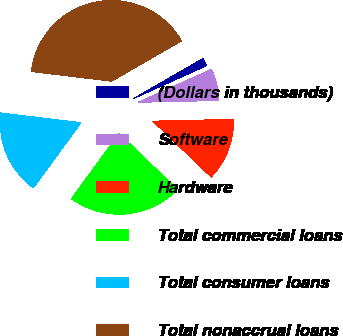Convert chart to OTSL. <chart><loc_0><loc_0><loc_500><loc_500><pie_chart><fcel>(Dollars in thousands)<fcel>Software<fcel>Hardware<fcel>Total commercial loans<fcel>Total consumer loans<fcel>Total nonaccrual loans<nl><fcel>1.59%<fcel>6.38%<fcel>12.52%<fcel>22.87%<fcel>16.88%<fcel>39.75%<nl></chart> 